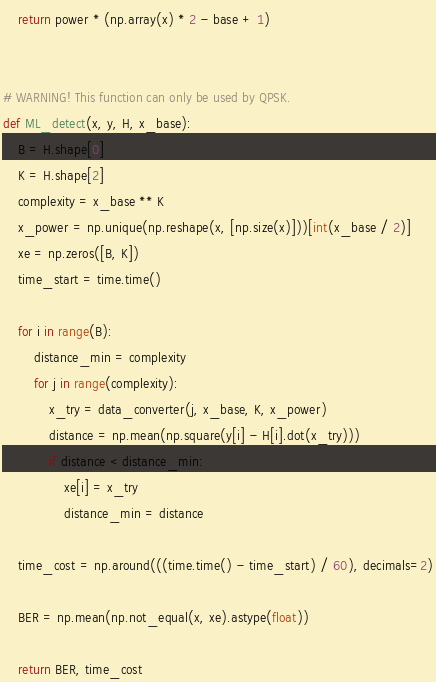Convert code to text. <code><loc_0><loc_0><loc_500><loc_500><_Python_>    return power * (np.array(x) * 2 - base + 1)


# WARNING! This function can only be used by QPSK.
def ML_detect(x, y, H, x_base):
    B = H.shape[0]
    K = H.shape[2]
    complexity = x_base ** K
    x_power = np.unique(np.reshape(x, [np.size(x)]))[int(x_base / 2)]
    xe = np.zeros([B, K])
    time_start = time.time()

    for i in range(B):
        distance_min = complexity
        for j in range(complexity):
            x_try = data_converter(j, x_base, K, x_power)
            distance = np.mean(np.square(y[i] - H[i].dot(x_try)))
            if distance < distance_min:
                xe[i] = x_try
                distance_min = distance

    time_cost = np.around(((time.time() - time_start) / 60), decimals=2)

    BER = np.mean(np.not_equal(x, xe).astype(float))

    return BER, time_cost
</code> 